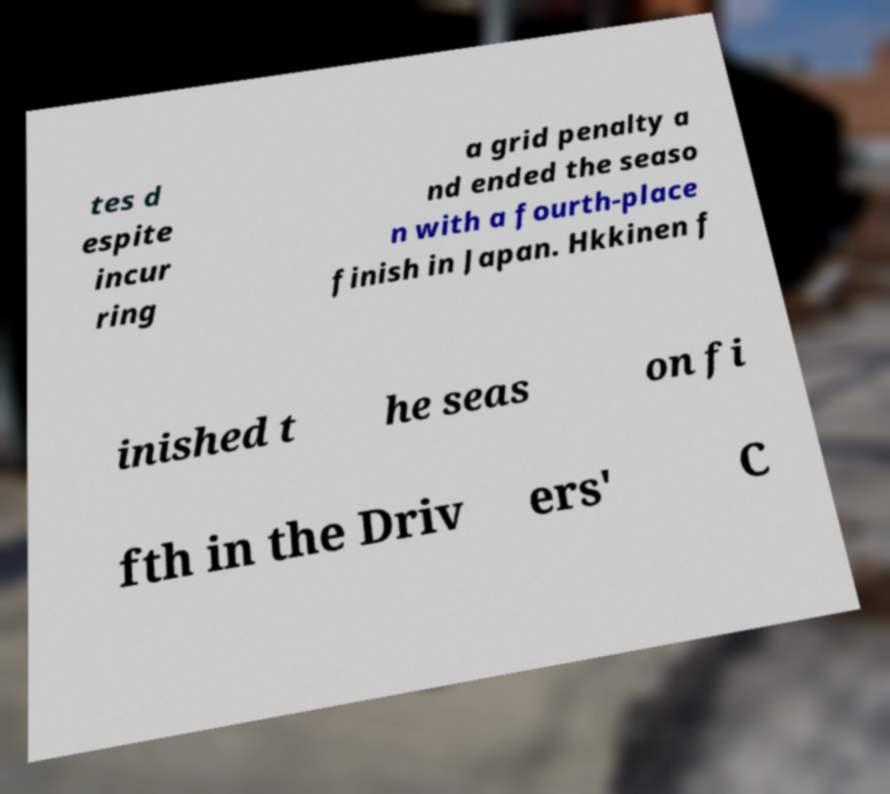Can you read and provide the text displayed in the image?This photo seems to have some interesting text. Can you extract and type it out for me? tes d espite incur ring a grid penalty a nd ended the seaso n with a fourth-place finish in Japan. Hkkinen f inished t he seas on fi fth in the Driv ers' C 